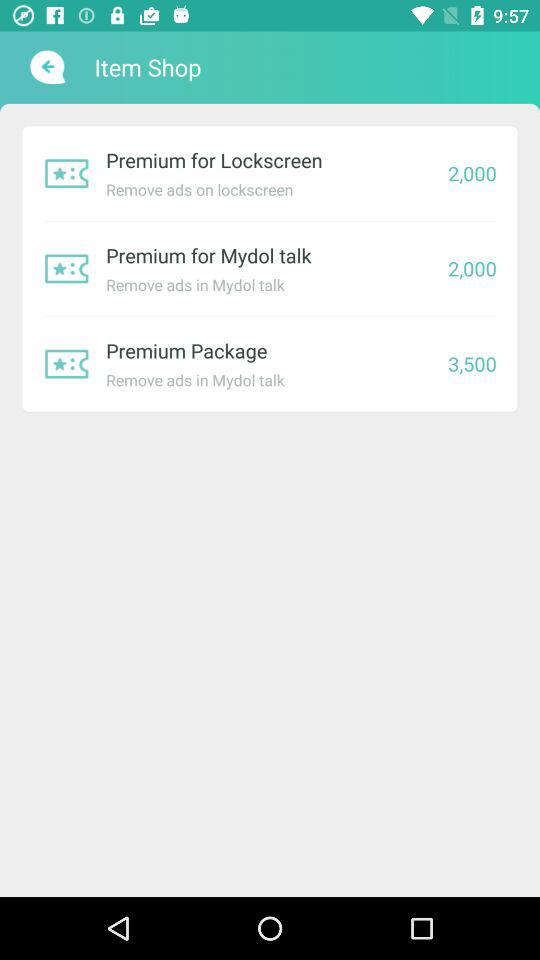How much more does the Premium Package cost than the Premium for Mydol Talk?
Answer the question using a single word or phrase. 1500 